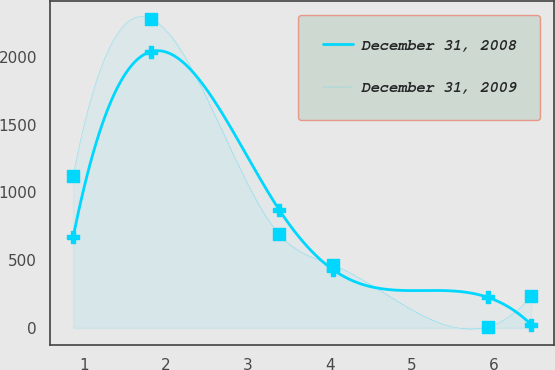<chart> <loc_0><loc_0><loc_500><loc_500><line_chart><ecel><fcel>December 31, 2008<fcel>December 31, 2009<nl><fcel>0.87<fcel>670.41<fcel>1122.15<nl><fcel>1.82<fcel>2038.48<fcel>2281.14<nl><fcel>3.38<fcel>871.75<fcel>690.64<nl><fcel>4.04<fcel>427.78<fcel>463.43<nl><fcel>5.92<fcel>226.44<fcel>9.01<nl><fcel>6.45<fcel>25.1<fcel>236.22<nl></chart> 